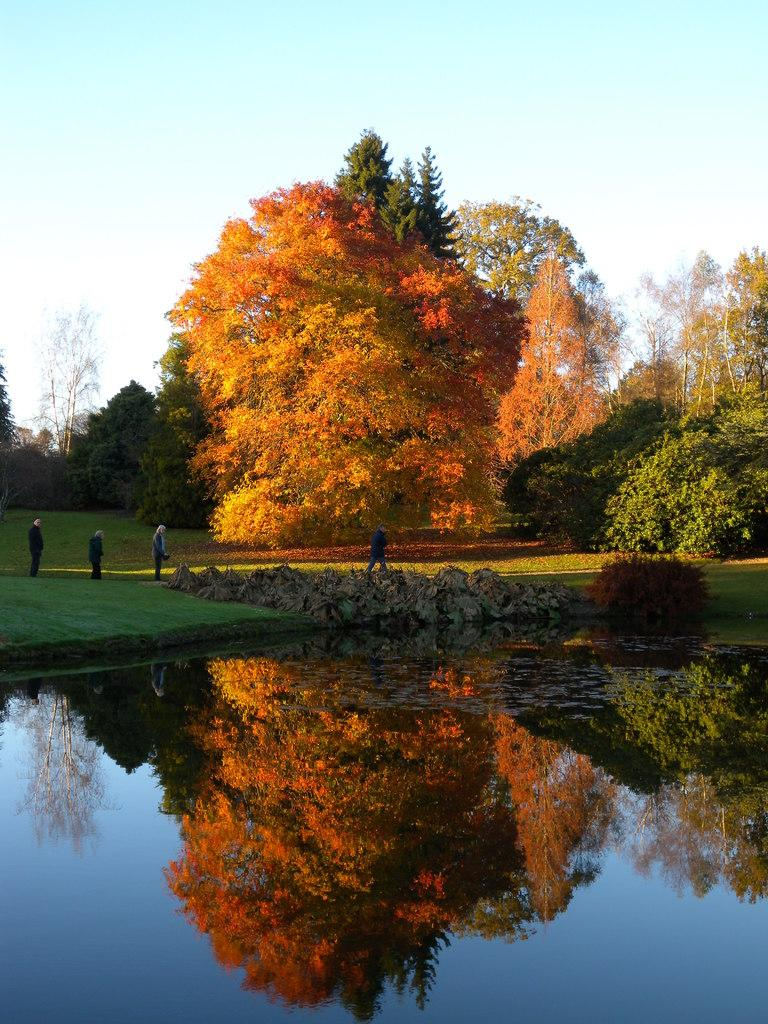What is happening on the ground in the image? There are people on the ground in the image. What natural element is visible in the image? There is water visible in the image. What type of vegetation can be seen in the image? There are trees in the image. What is visible in the background of the image? The sky is visible in the background of the image. How many cats are sitting on the sheet in the image? There are no cats or sheets present in the image. What type of engine can be seen powering the boat in the image? There is no boat or engine present in the image. 